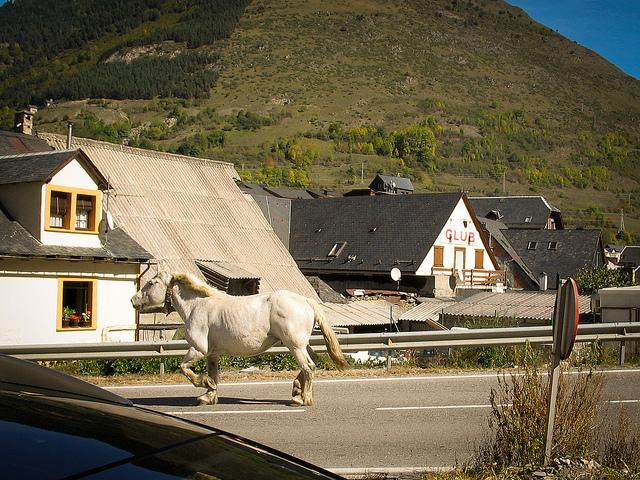Why are the roofs at street level? Please explain your reasoning. street below. The road is actually elevated and the whole houses are below. 